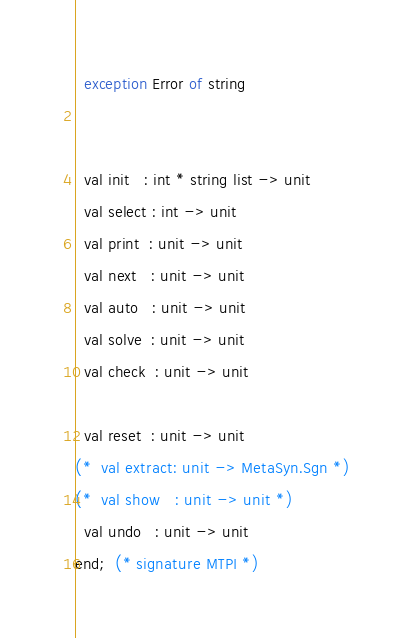Convert code to text. <code><loc_0><loc_0><loc_500><loc_500><_SML_>  exception Error of string 
  

  val init   : int * string list -> unit
  val select : int -> unit 
  val print  : unit -> unit
  val next   : unit -> unit
  val auto   : unit -> unit
  val solve  : unit -> unit
  val check  : unit -> unit

  val reset  : unit -> unit
(*  val extract: unit -> MetaSyn.Sgn *)
(*  val show   : unit -> unit *)
  val undo   : unit -> unit 
end;  (* signature MTPI *)


</code> 